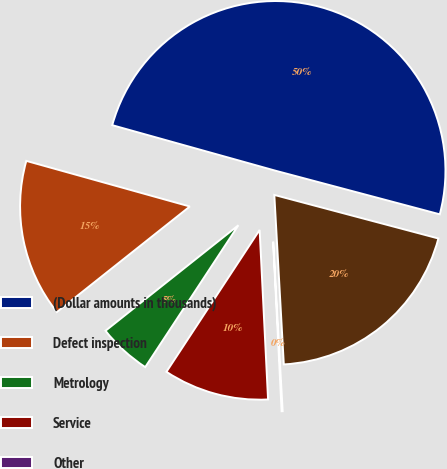<chart> <loc_0><loc_0><loc_500><loc_500><pie_chart><fcel>(Dollar amounts in thousands)<fcel>Defect inspection<fcel>Metrology<fcel>Service<fcel>Other<fcel>Total<nl><fcel>49.8%<fcel>15.01%<fcel>5.07%<fcel>10.04%<fcel>0.1%<fcel>19.98%<nl></chart> 